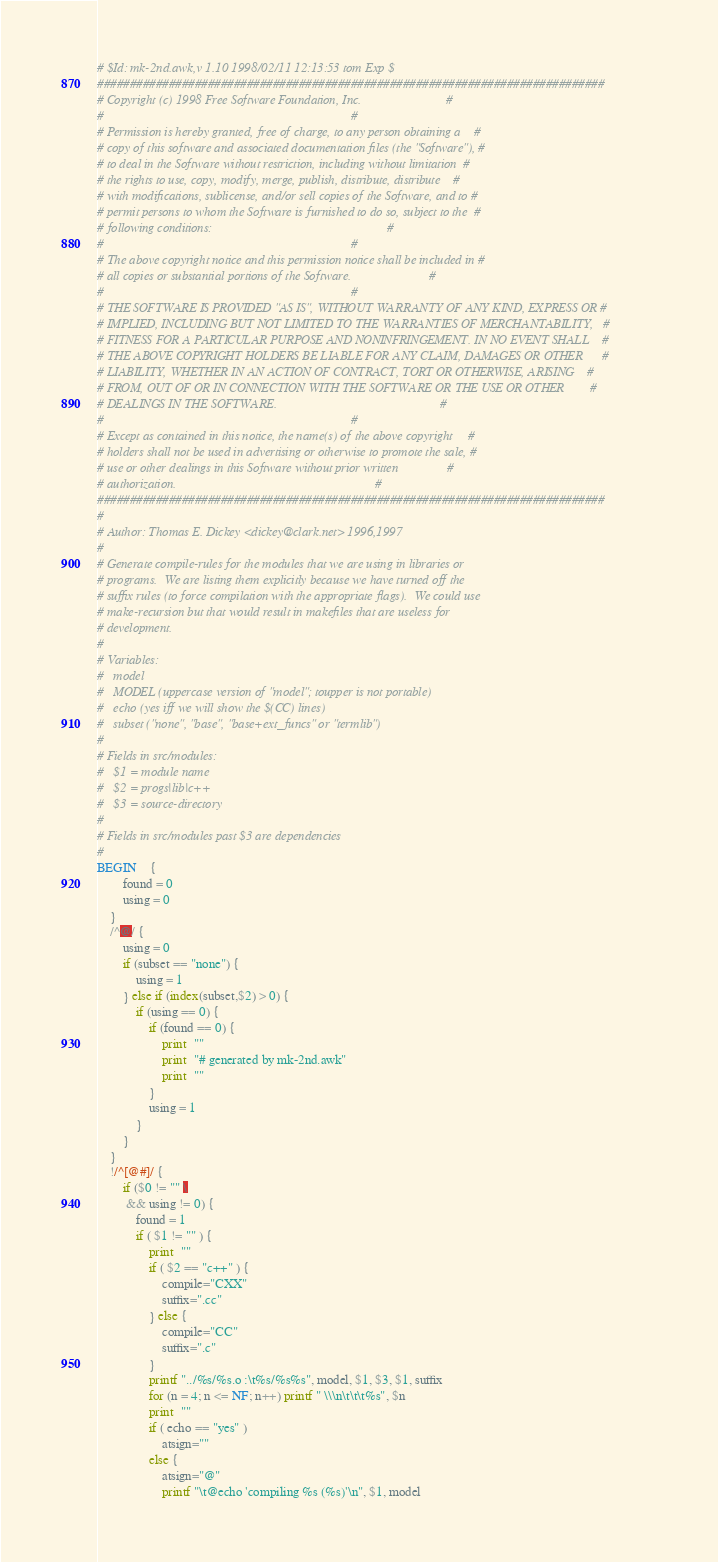Convert code to text. <code><loc_0><loc_0><loc_500><loc_500><_Awk_># $Id: mk-2nd.awk,v 1.10 1998/02/11 12:13:53 tom Exp $
##############################################################################
# Copyright (c) 1998 Free Software Foundation, Inc.                          #
#                                                                            #
# Permission is hereby granted, free of charge, to any person obtaining a    #
# copy of this software and associated documentation files (the "Software"), #
# to deal in the Software without restriction, including without limitation  #
# the rights to use, copy, modify, merge, publish, distribute, distribute    #
# with modifications, sublicense, and/or sell copies of the Software, and to #
# permit persons to whom the Software is furnished to do so, subject to the  #
# following conditions:                                                      #
#                                                                            #
# The above copyright notice and this permission notice shall be included in #
# all copies or substantial portions of the Software.                        #
#                                                                            #
# THE SOFTWARE IS PROVIDED "AS IS", WITHOUT WARRANTY OF ANY KIND, EXPRESS OR #
# IMPLIED, INCLUDING BUT NOT LIMITED TO THE WARRANTIES OF MERCHANTABILITY,   #
# FITNESS FOR A PARTICULAR PURPOSE AND NONINFRINGEMENT. IN NO EVENT SHALL    #
# THE ABOVE COPYRIGHT HOLDERS BE LIABLE FOR ANY CLAIM, DAMAGES OR OTHER      #
# LIABILITY, WHETHER IN AN ACTION OF CONTRACT, TORT OR OTHERWISE, ARISING    #
# FROM, OUT OF OR IN CONNECTION WITH THE SOFTWARE OR THE USE OR OTHER        #
# DEALINGS IN THE SOFTWARE.                                                  #
#                                                                            #
# Except as contained in this notice, the name(s) of the above copyright     #
# holders shall not be used in advertising or otherwise to promote the sale, #
# use or other dealings in this Software without prior written               #
# authorization.                                                             #
##############################################################################
#
# Author: Thomas E. Dickey <dickey@clark.net> 1996,1997
#
# Generate compile-rules for the modules that we are using in libraries or
# programs.  We are listing them explicitly because we have turned off the
# suffix rules (to force compilation with the appropriate flags).  We could use
# make-recursion but that would result in makefiles that are useless for
# development.
#
# Variables:
#	model
#	MODEL (uppercase version of "model"; toupper is not portable)
#	echo (yes iff we will show the $(CC) lines)
#	subset ("none", "base", "base+ext_funcs" or "termlib")
#
# Fields in src/modules:
#	$1 = module name
#	$2 = progs|lib|c++
#	$3 = source-directory
#
# Fields in src/modules past $3 are dependencies
#
BEGIN	{
		found = 0
		using = 0
	}
	/^@/ {
		using = 0
		if (subset == "none") {
			using = 1
		} else if (index(subset,$2) > 0) {
			if (using == 0) {
				if (found == 0) {
					print  ""
					print  "# generated by mk-2nd.awk"
					print  ""
				}
				using = 1
			}
		}
	}
	!/^[@#]/ {
		if ($0 != "" \
		 && using != 0) {
			found = 1
			if ( $1 != "" ) {
				print  ""
				if ( $2 == "c++" ) {
					compile="CXX"
					suffix=".cc"
				} else {
					compile="CC"
					suffix=".c"
				}
				printf "../%s/%s.o :\t%s/%s%s", model, $1, $3, $1, suffix
				for (n = 4; n <= NF; n++) printf " \\\n\t\t\t%s", $n
				print  ""
				if ( echo == "yes" )
					atsign=""
				else {
					atsign="@"
					printf "\t@echo 'compiling %s (%s)'\n", $1, model</code> 